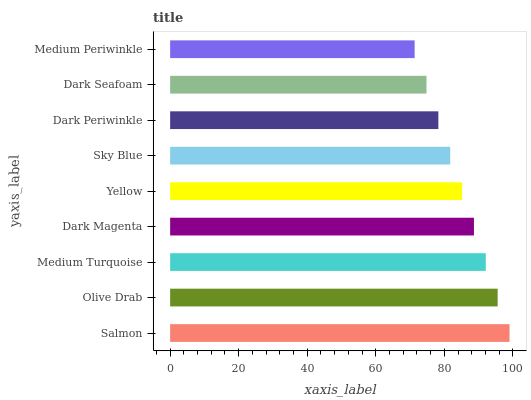Is Medium Periwinkle the minimum?
Answer yes or no. Yes. Is Salmon the maximum?
Answer yes or no. Yes. Is Olive Drab the minimum?
Answer yes or no. No. Is Olive Drab the maximum?
Answer yes or no. No. Is Salmon greater than Olive Drab?
Answer yes or no. Yes. Is Olive Drab less than Salmon?
Answer yes or no. Yes. Is Olive Drab greater than Salmon?
Answer yes or no. No. Is Salmon less than Olive Drab?
Answer yes or no. No. Is Yellow the high median?
Answer yes or no. Yes. Is Yellow the low median?
Answer yes or no. Yes. Is Medium Periwinkle the high median?
Answer yes or no. No. Is Medium Periwinkle the low median?
Answer yes or no. No. 